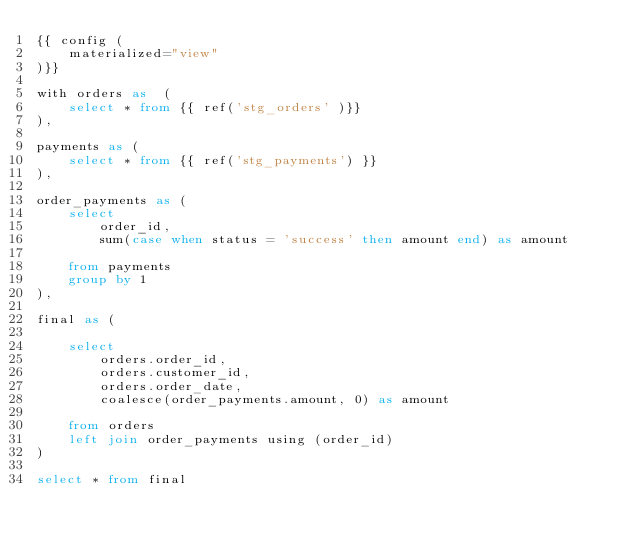<code> <loc_0><loc_0><loc_500><loc_500><_SQL_>{{ config (
    materialized="view"
)}}

with orders as  (
    select * from {{ ref('stg_orders' )}}
),

payments as (
    select * from {{ ref('stg_payments') }}
),

order_payments as (
    select
        order_id,
        sum(case when status = 'success' then amount end) as amount

    from payments
    group by 1
),

final as (

    select
        orders.order_id,
        orders.customer_id,
        orders.order_date,
        coalesce(order_payments.amount, 0) as amount

    from orders
    left join order_payments using (order_id)
)

select * from final</code> 